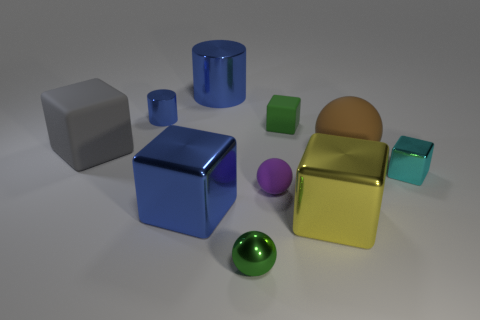What material is the small ball that is the same color as the tiny rubber cube?
Provide a short and direct response. Metal. Do the big blue thing that is in front of the cyan cube and the green thing to the left of the purple matte sphere have the same material?
Ensure brevity in your answer.  Yes. Are there more tiny blue metallic cylinders than cyan balls?
Your answer should be compact. Yes. The shiny cylinder that is in front of the blue shiny cylinder that is right of the small thing on the left side of the big blue cube is what color?
Ensure brevity in your answer.  Blue. Does the large metallic cube that is on the left side of the tiny purple object have the same color as the metal cylinder that is on the right side of the blue metal cube?
Offer a terse response. Yes. There is a big rubber thing that is right of the gray object; what number of large yellow metallic cubes are on the right side of it?
Provide a succinct answer. 0. Are there any small gray matte cylinders?
Offer a terse response. No. What number of other objects are the same color as the tiny shiny sphere?
Your response must be concise. 1. Are there fewer small metallic cylinders than metal cylinders?
Your answer should be very brief. Yes. There is a brown rubber object behind the object in front of the big yellow object; what shape is it?
Your answer should be compact. Sphere. 